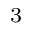<formula> <loc_0><loc_0><loc_500><loc_500>^ { 3 }</formula> 